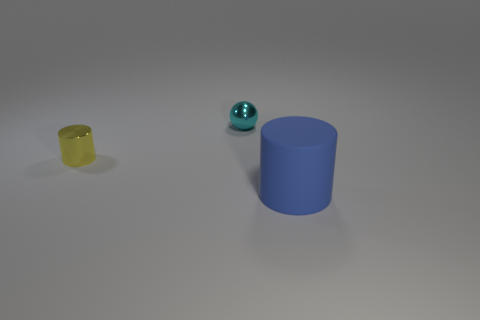Add 3 small cyan metallic cylinders. How many objects exist? 6 Add 1 cyan things. How many cyan things are left? 2 Add 1 small cyan shiny spheres. How many small cyan shiny spheres exist? 2 Subtract all yellow cylinders. How many cylinders are left? 1 Subtract 1 cyan spheres. How many objects are left? 2 Subtract all cylinders. How many objects are left? 1 Subtract all gray cylinders. Subtract all blue spheres. How many cylinders are left? 2 Subtract all tiny things. Subtract all gray matte things. How many objects are left? 1 